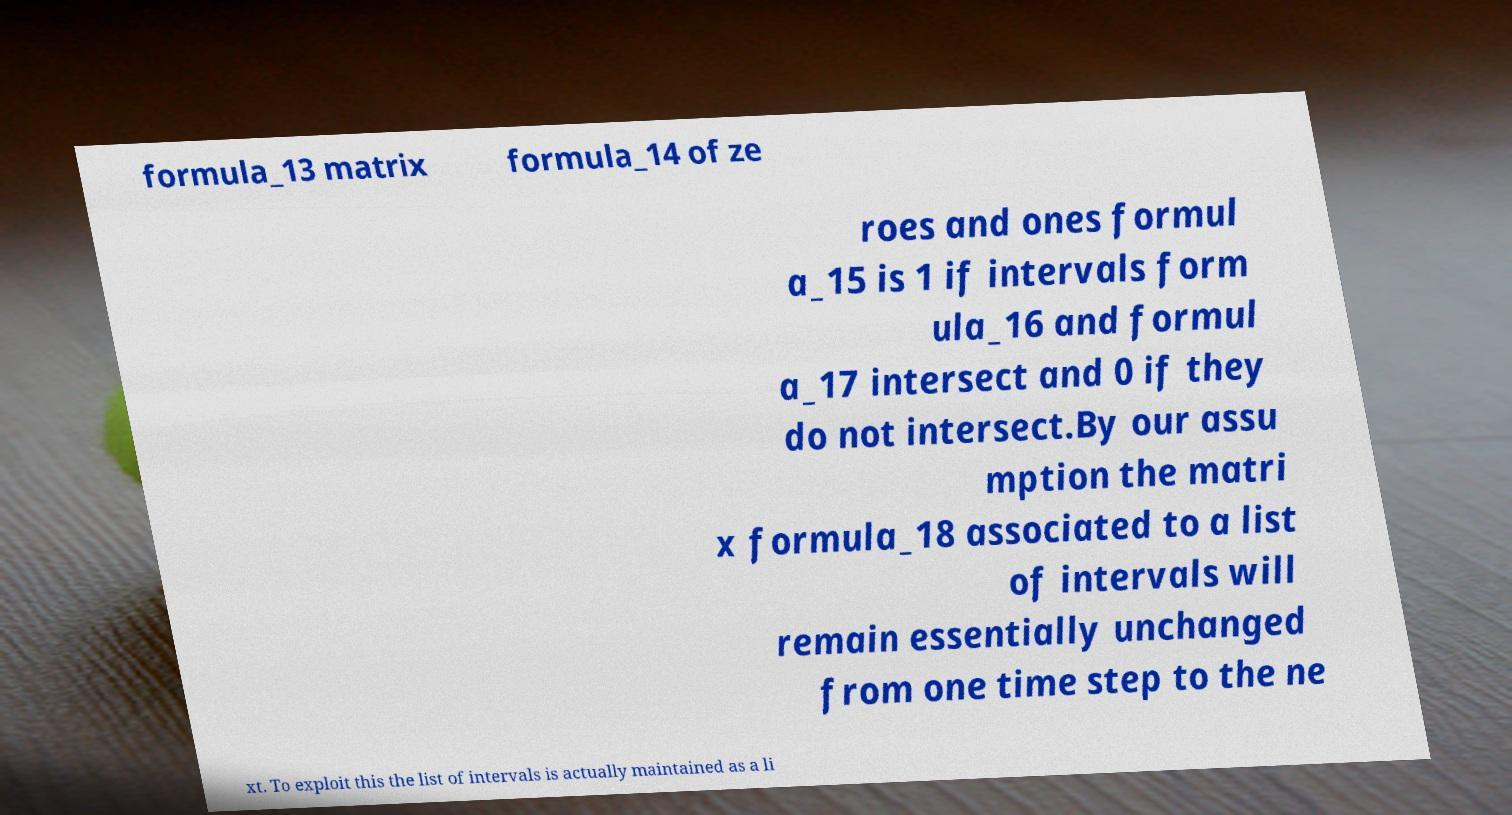Can you read and provide the text displayed in the image?This photo seems to have some interesting text. Can you extract and type it out for me? formula_13 matrix formula_14 of ze roes and ones formul a_15 is 1 if intervals form ula_16 and formul a_17 intersect and 0 if they do not intersect.By our assu mption the matri x formula_18 associated to a list of intervals will remain essentially unchanged from one time step to the ne xt. To exploit this the list of intervals is actually maintained as a li 